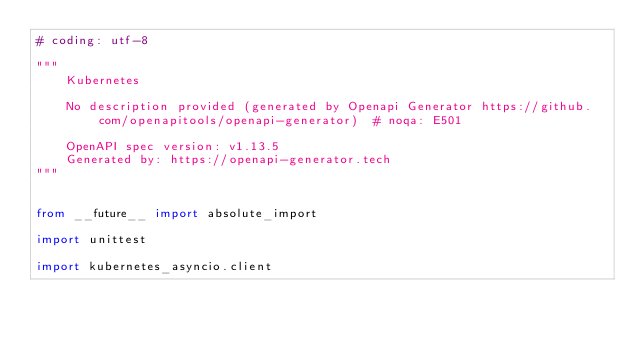<code> <loc_0><loc_0><loc_500><loc_500><_Python_># coding: utf-8

"""
    Kubernetes

    No description provided (generated by Openapi Generator https://github.com/openapitools/openapi-generator)  # noqa: E501

    OpenAPI spec version: v1.13.5
    Generated by: https://openapi-generator.tech
"""


from __future__ import absolute_import

import unittest

import kubernetes_asyncio.client</code> 